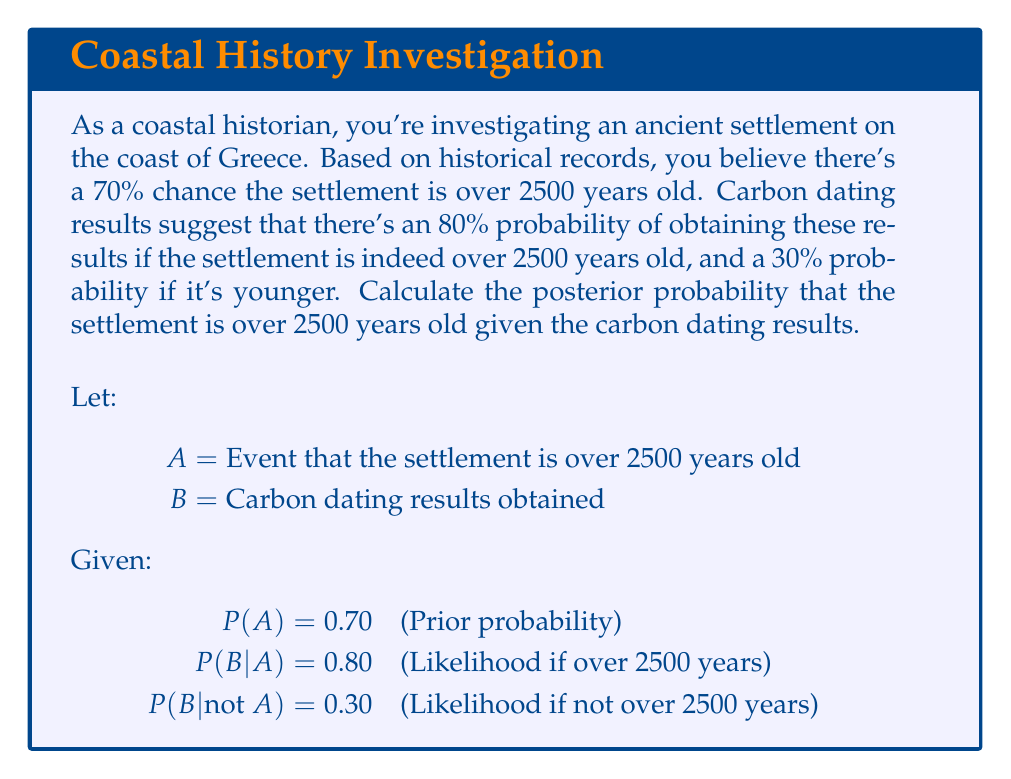Give your solution to this math problem. To solve this problem, we'll use Bayes' Theorem:

$$P(A|B) = \frac{P(B|A) \cdot P(A)}{P(B)}$$

Step 1: Calculate P(B) using the law of total probability
$$P(B) = P(B|A) \cdot P(A) + P(B|\text{not }A) \cdot P(\text{not }A)$$
$$P(B) = 0.80 \cdot 0.70 + 0.30 \cdot (1 - 0.70)$$
$$P(B) = 0.56 + 0.09 = 0.65$$

Step 2: Apply Bayes' Theorem
$$P(A|B) = \frac{0.80 \cdot 0.70}{0.65}$$

Step 3: Calculate the final result
$$P(A|B) = \frac{0.56}{0.65} \approx 0.8615$$

Therefore, the posterior probability that the settlement is over 2500 years old, given the carbon dating results, is approximately 0.8615 or 86.15%.
Answer: 0.8615 (or 86.15%) 